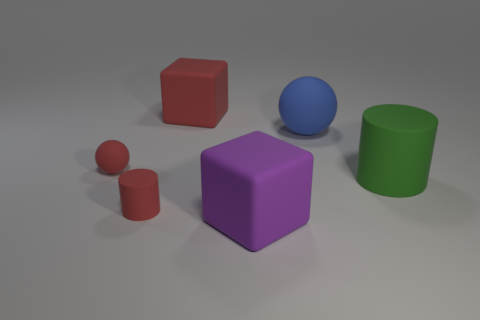Add 1 purple blocks. How many objects exist? 7 Subtract all red blocks. How many blocks are left? 1 Subtract all cylinders. How many objects are left? 4 Subtract 1 cylinders. How many cylinders are left? 1 Subtract all tiny red metal cubes. Subtract all tiny red matte things. How many objects are left? 4 Add 1 large cylinders. How many large cylinders are left? 2 Add 5 large purple things. How many large purple things exist? 6 Subtract 1 red blocks. How many objects are left? 5 Subtract all green cubes. Subtract all cyan spheres. How many cubes are left? 2 